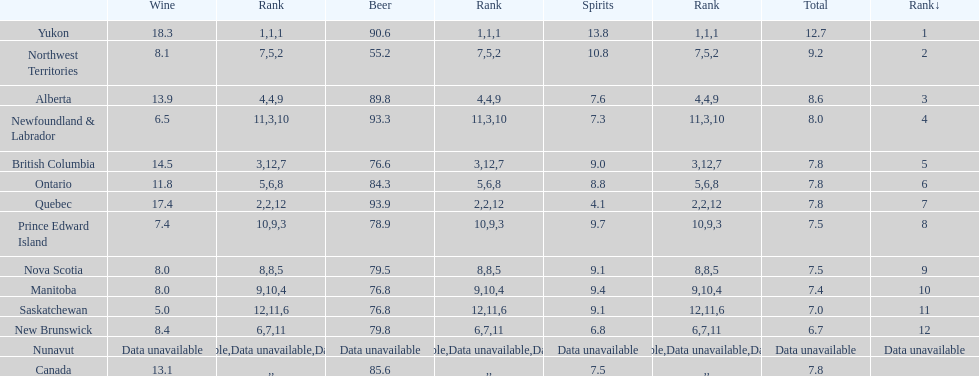How many litres do individuals in yukon consume in spirits per year? 12.7. 